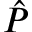Convert formula to latex. <formula><loc_0><loc_0><loc_500><loc_500>\hat { P }</formula> 